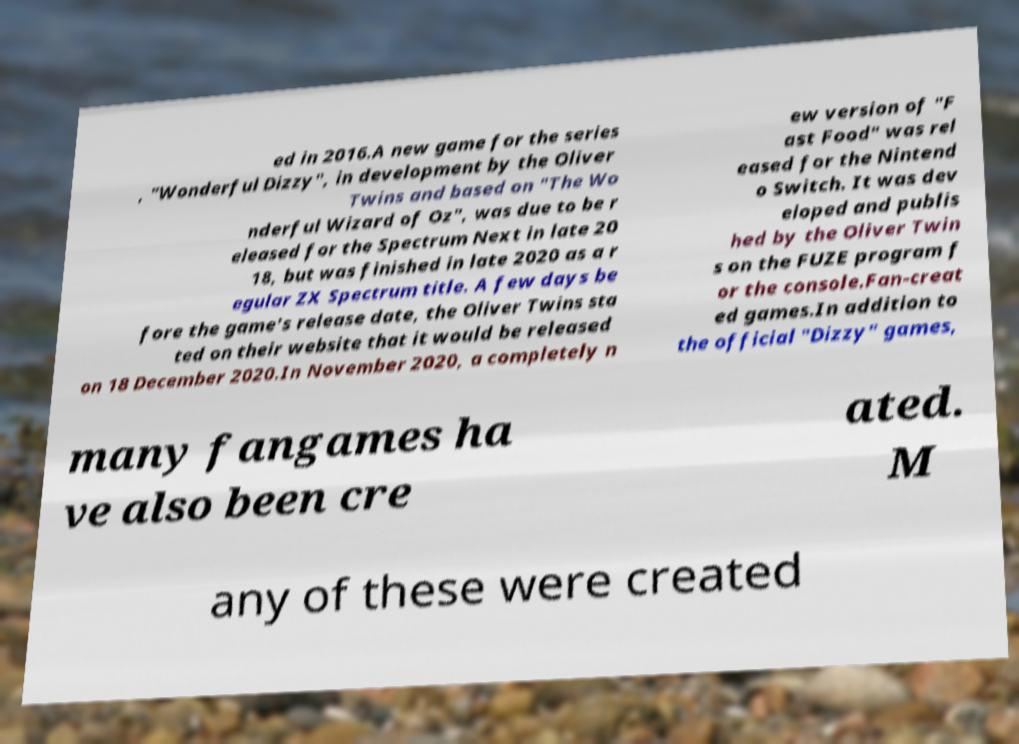For documentation purposes, I need the text within this image transcribed. Could you provide that? ed in 2016.A new game for the series , "Wonderful Dizzy", in development by the Oliver Twins and based on "The Wo nderful Wizard of Oz", was due to be r eleased for the Spectrum Next in late 20 18, but was finished in late 2020 as a r egular ZX Spectrum title. A few days be fore the game's release date, the Oliver Twins sta ted on their website that it would be released on 18 December 2020.In November 2020, a completely n ew version of "F ast Food" was rel eased for the Nintend o Switch. It was dev eloped and publis hed by the Oliver Twin s on the FUZE program f or the console.Fan-creat ed games.In addition to the official "Dizzy" games, many fangames ha ve also been cre ated. M any of these were created 